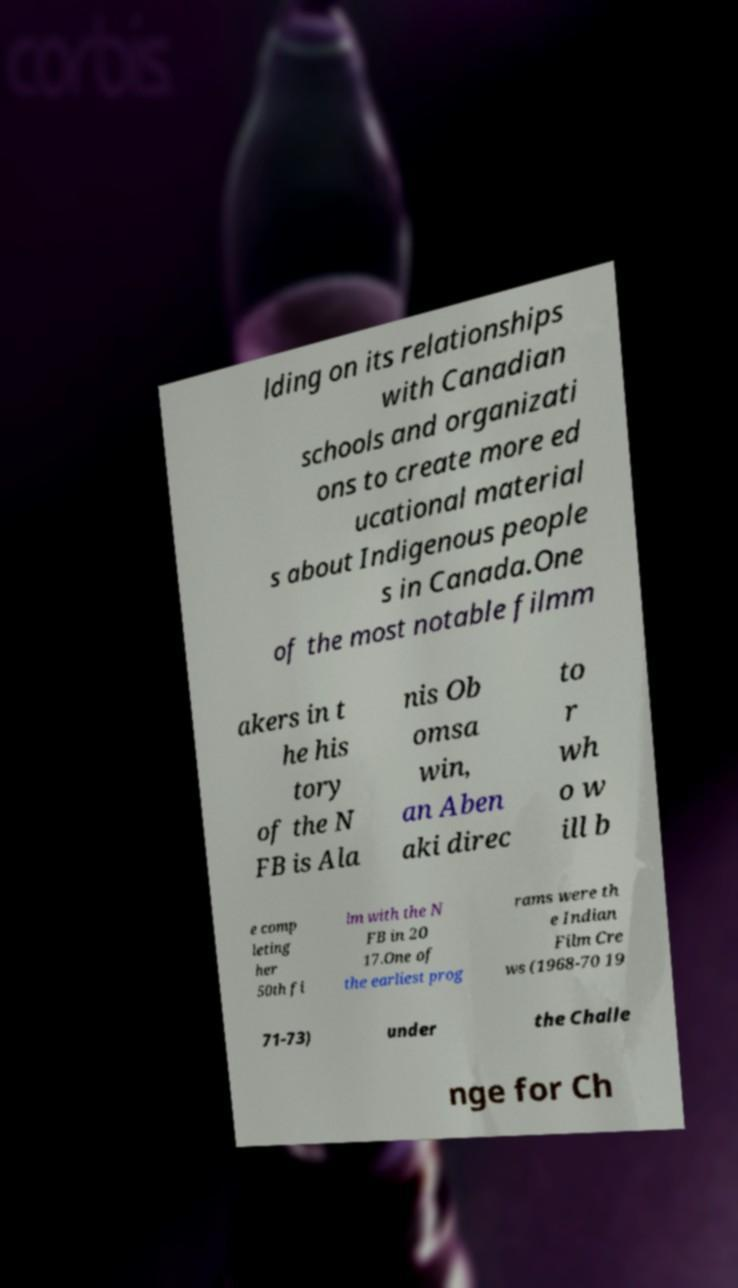For documentation purposes, I need the text within this image transcribed. Could you provide that? lding on its relationships with Canadian schools and organizati ons to create more ed ucational material s about Indigenous people s in Canada.One of the most notable filmm akers in t he his tory of the N FB is Ala nis Ob omsa win, an Aben aki direc to r wh o w ill b e comp leting her 50th fi lm with the N FB in 20 17.One of the earliest prog rams were th e Indian Film Cre ws (1968-70 19 71-73) under the Challe nge for Ch 